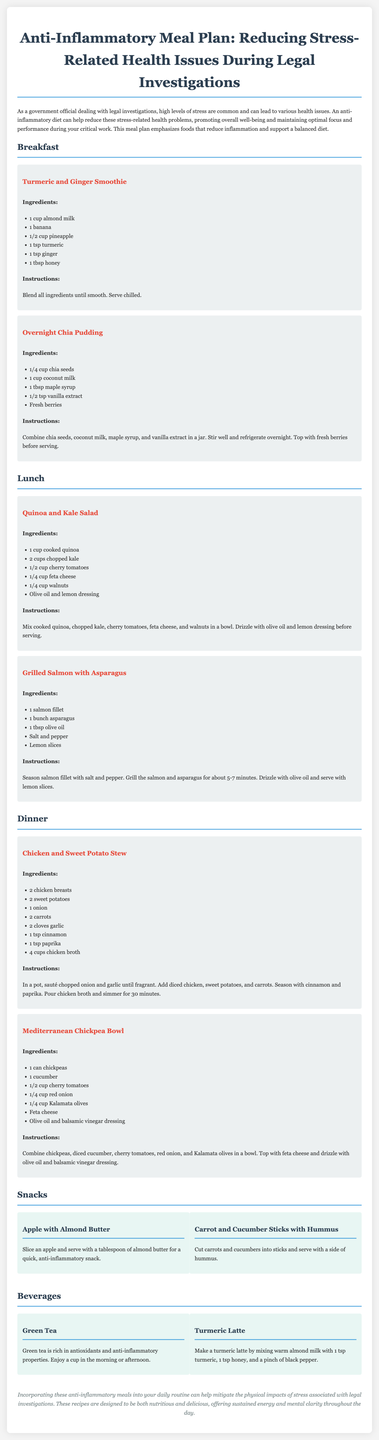What is the title of the document? The title is specified in the document header, presenting the theme and focus of the content.
Answer: Anti-Inflammatory Meal Plan: Reducing Stress-Related Health Issues During Legal Investigations How many ingredients are in the Turmeric and Ginger Smoothie? The recipe lists a total of 6 specific ingredients for the smoothie.
Answer: 6 What type of beverage is suggested for an anti-inflammatory option? The document categorizes beverages and provides specific examples to promote anti-inflammatory properties.
Answer: Green Tea What is the main ingredient in the Overnight Chia Pudding? The document highlights chia seeds as the key component in this meal preparation.
Answer: Chia seeds How long should the Chicken and Sweet Potato Stew simmer? The cooking instructions explicitly mention the duration for simmering the stew.
Answer: 30 minutes What dressing is used for the Quinoa and Kale Salad? The preparation instructions specify the components used as dressing for the salad.
Answer: Olive oil and lemon dressing Which meal contains salmon? The meal details identify specific foods, revealing the presence of salmon in one of the recipes.
Answer: Grilled Salmon with Asparagus What is the primary use of the anti-inflammatory meal plan? The introductory section outlines the goal and purpose of implementing this meal plan.
Answer: Reduce stress-related health problems 